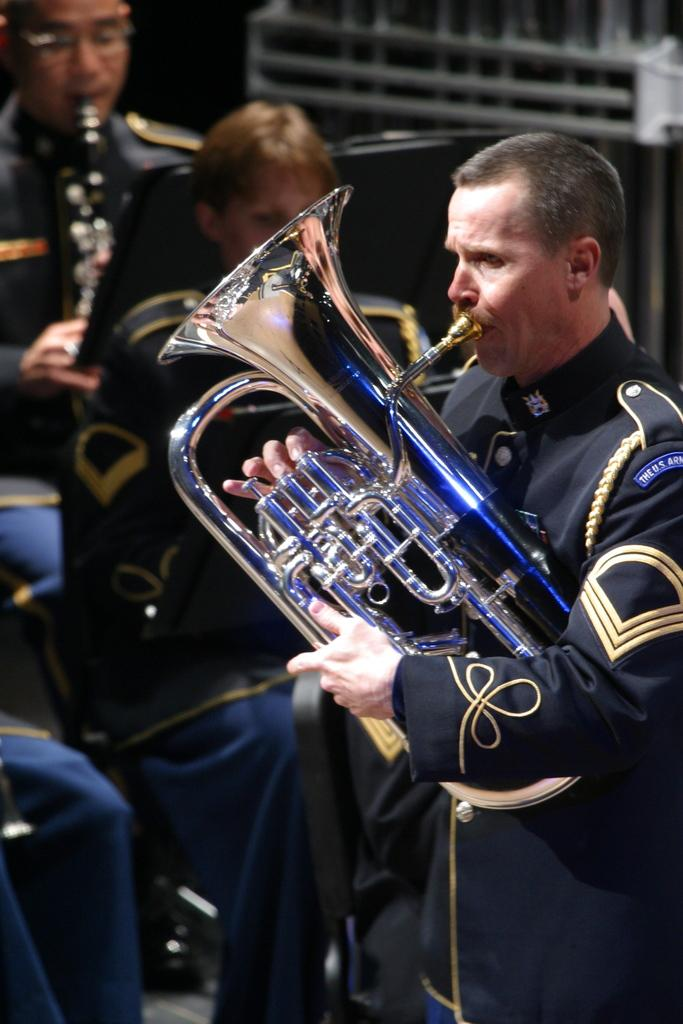What is the main subject of the image? There is a person standing in the center of the image. What is the person in the center holding? The person is holding a saxophone. What can be seen in the background of the image? In the background, there are persons sitting. What are the persons in the background holding? The persons in the background are holding musical instruments. What type of berry can be seen growing on the saxophone in the image? There are no berries present on the saxophone in the image. How many steps are taken by the person holding the saxophone in the image? The image does not show the person taking any steps, as they are standing still while holding the saxophone. 